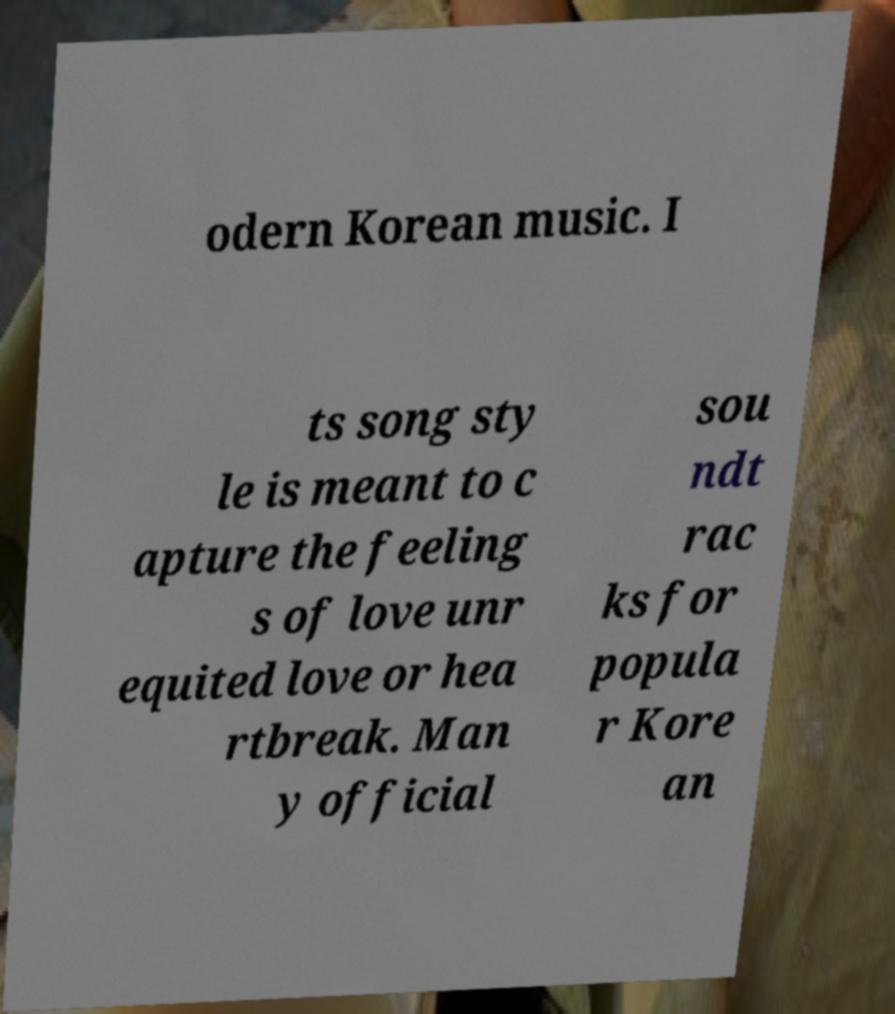Can you read and provide the text displayed in the image?This photo seems to have some interesting text. Can you extract and type it out for me? odern Korean music. I ts song sty le is meant to c apture the feeling s of love unr equited love or hea rtbreak. Man y official sou ndt rac ks for popula r Kore an 